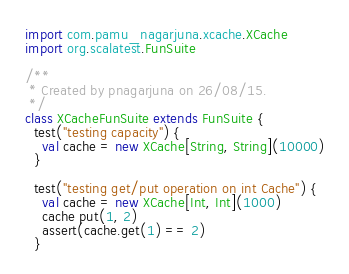<code> <loc_0><loc_0><loc_500><loc_500><_Scala_>import com.pamu_nagarjuna.xcache.XCache
import org.scalatest.FunSuite

/**
 * Created by pnagarjuna on 26/08/15.
 */
class XCacheFunSuite extends FunSuite {
  test("testing capacity") {
    val cache = new XCache[String, String](10000)
  }

  test("testing get/put operation on int Cache") {
    val cache = new XCache[Int, Int](1000)
    cache put(1, 2)
    assert(cache.get(1) == 2)
  }
</code> 